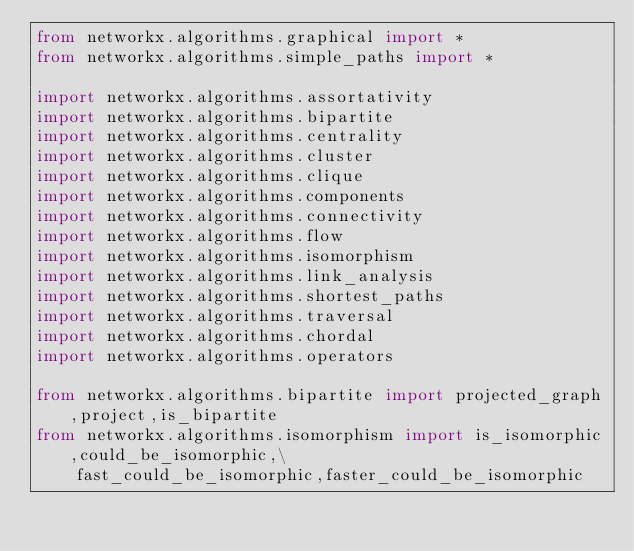Convert code to text. <code><loc_0><loc_0><loc_500><loc_500><_Python_>from networkx.algorithms.graphical import *
from networkx.algorithms.simple_paths import *

import networkx.algorithms.assortativity
import networkx.algorithms.bipartite
import networkx.algorithms.centrality
import networkx.algorithms.cluster
import networkx.algorithms.clique
import networkx.algorithms.components
import networkx.algorithms.connectivity
import networkx.algorithms.flow
import networkx.algorithms.isomorphism
import networkx.algorithms.link_analysis
import networkx.algorithms.shortest_paths
import networkx.algorithms.traversal
import networkx.algorithms.chordal
import networkx.algorithms.operators

from networkx.algorithms.bipartite import projected_graph,project,is_bipartite
from networkx.algorithms.isomorphism import is_isomorphic,could_be_isomorphic,\
    fast_could_be_isomorphic,faster_could_be_isomorphic
</code> 